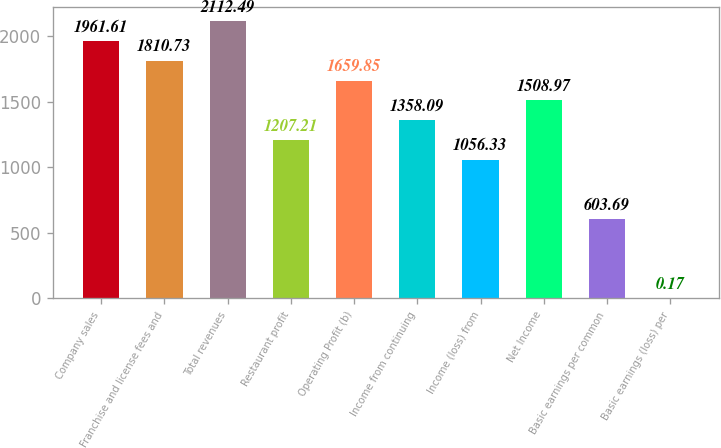Convert chart. <chart><loc_0><loc_0><loc_500><loc_500><bar_chart><fcel>Company sales<fcel>Franchise and license fees and<fcel>Total revenues<fcel>Restaurant profit<fcel>Operating Profit (b)<fcel>Income from continuing<fcel>Income (loss) from<fcel>Net Income<fcel>Basic earnings per common<fcel>Basic earnings (loss) per<nl><fcel>1961.61<fcel>1810.73<fcel>2112.49<fcel>1207.21<fcel>1659.85<fcel>1358.09<fcel>1056.33<fcel>1508.97<fcel>603.69<fcel>0.17<nl></chart> 